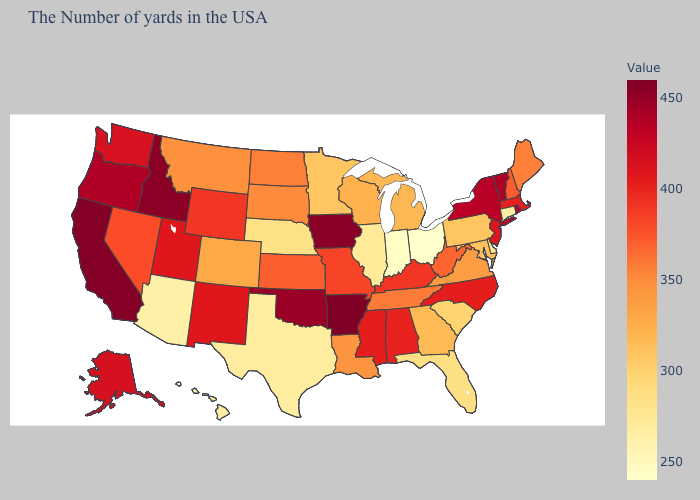Does Florida have the highest value in the USA?
Give a very brief answer. No. Does New Jersey have the lowest value in the USA?
Give a very brief answer. No. Among the states that border Connecticut , does New York have the highest value?
Answer briefly. Yes. Which states hav the highest value in the Northeast?
Quick response, please. Vermont. Which states have the lowest value in the MidWest?
Concise answer only. Ohio. Does Ohio have the lowest value in the USA?
Give a very brief answer. Yes. 